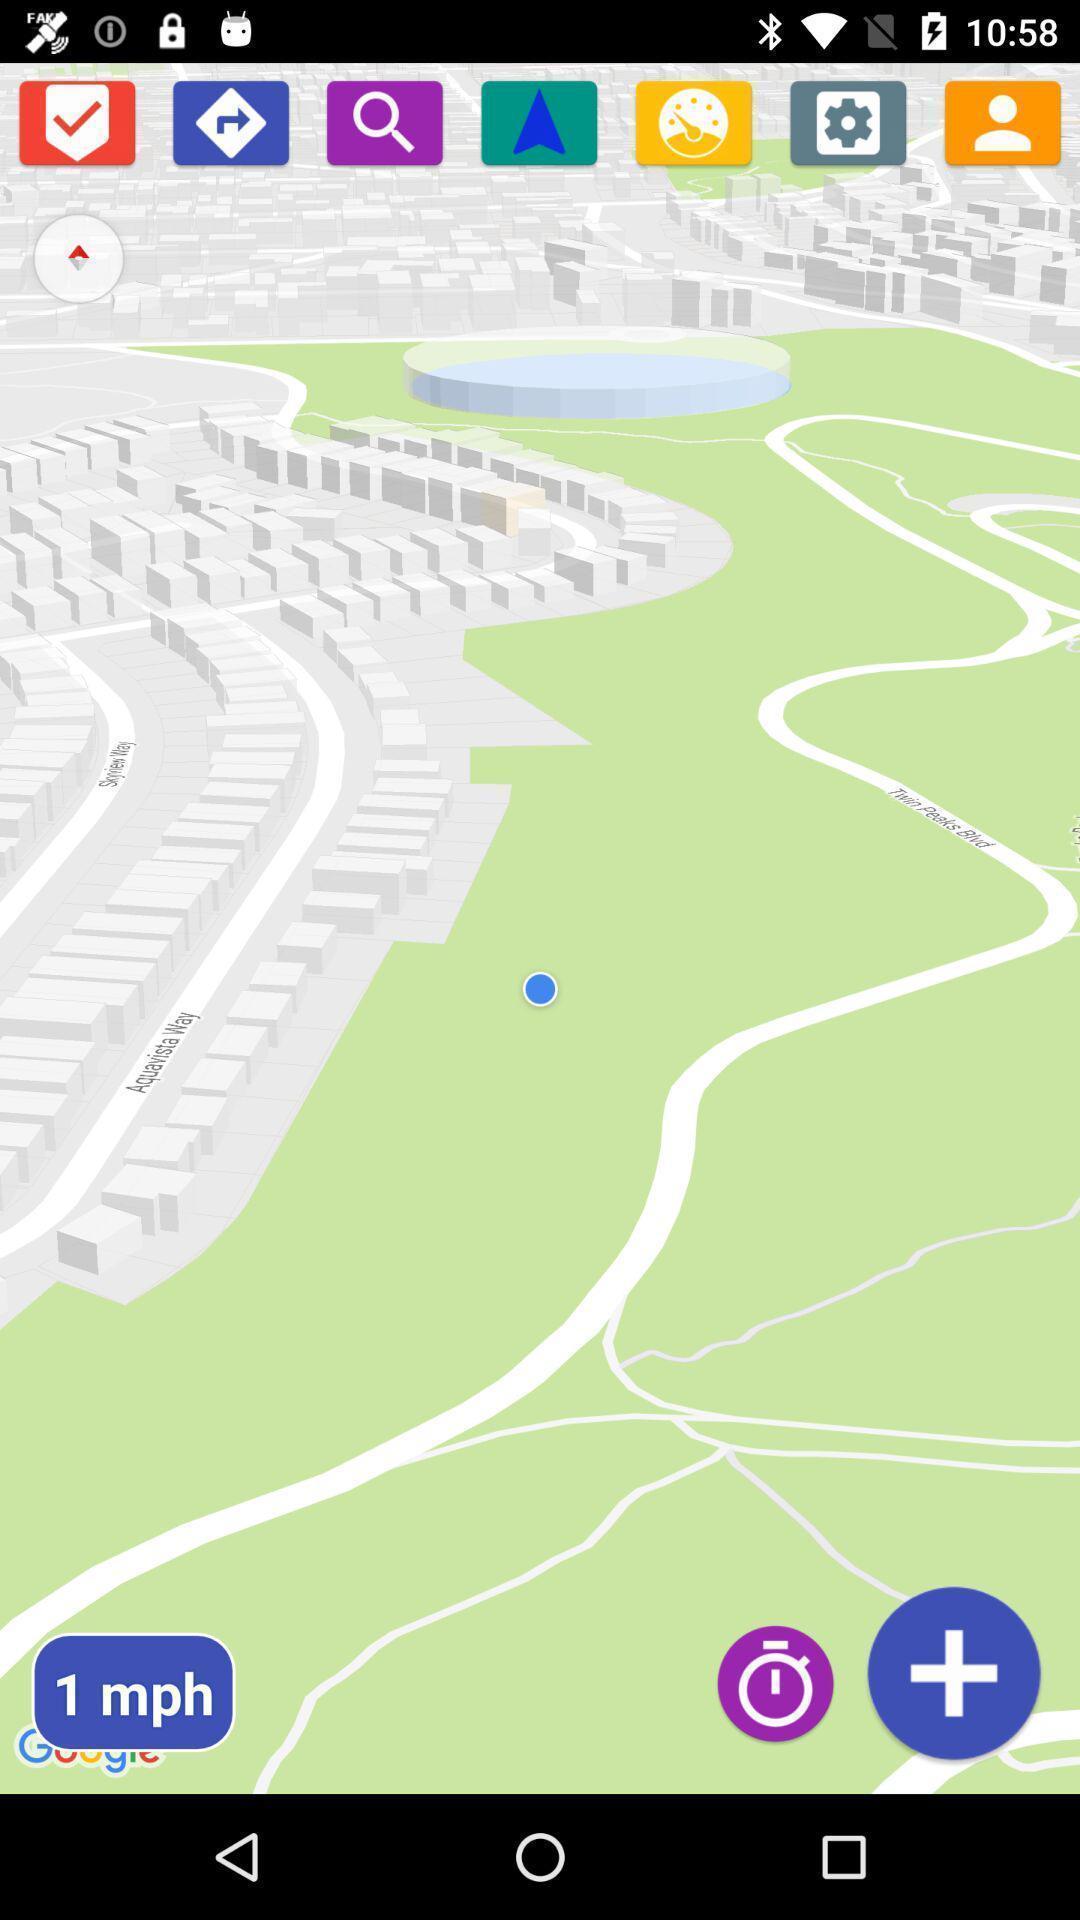Please provide a description for this image. Page showing different applications. 